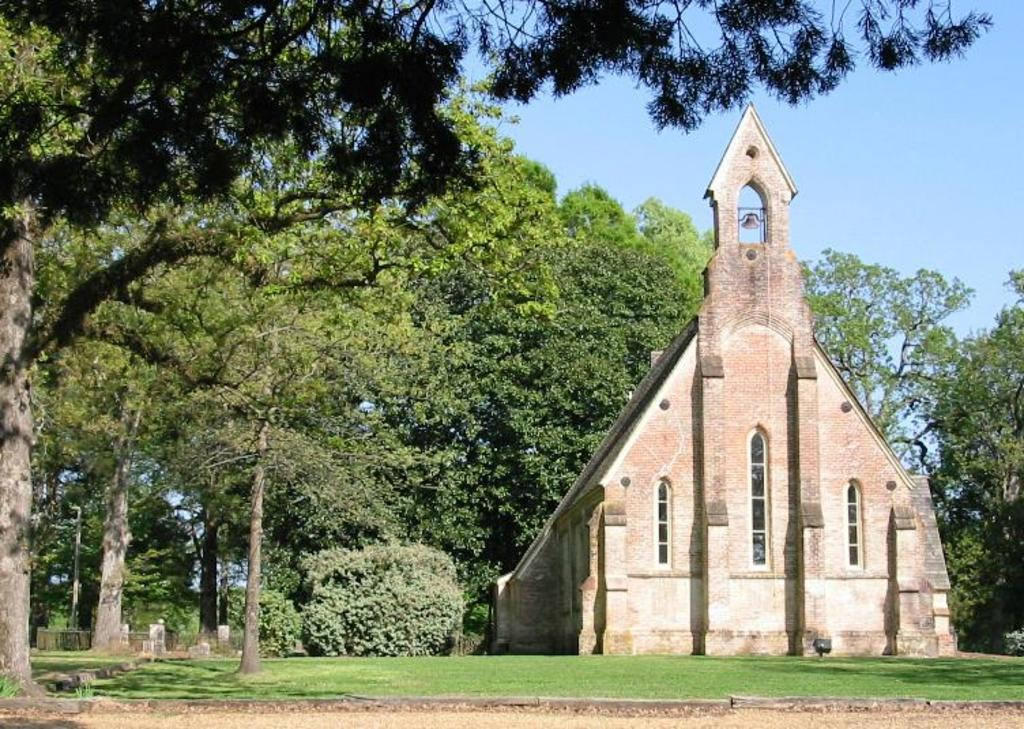What type of vegetation is present in the image? There are trees in the image. What is at the bottom of the image? There is grass at the bottom of the image. Where is the building located in the image? The building is on the right side of the image. What can be seen in the background of the image? The sky is visible in the background of the image. What type of stick can be seen in the image? There is no stick present in the image. How does the thunder move in the image? There is no thunder present in the image; it is a still image. 